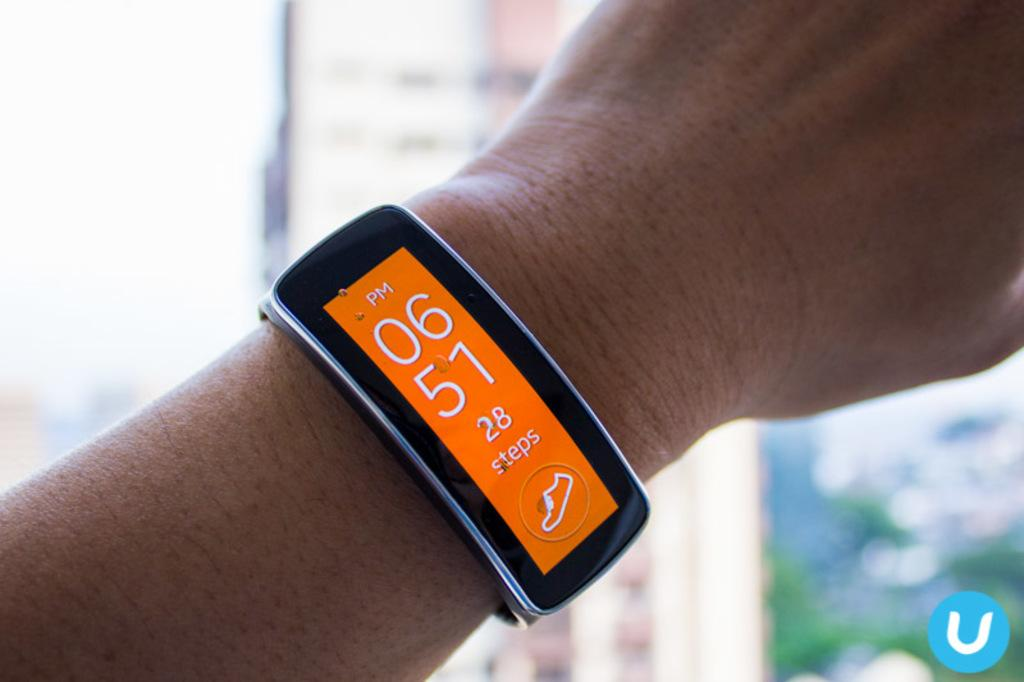<image>
Relay a brief, clear account of the picture shown. A smart watch with an orange screen shows that the user has 28 steps so far. 